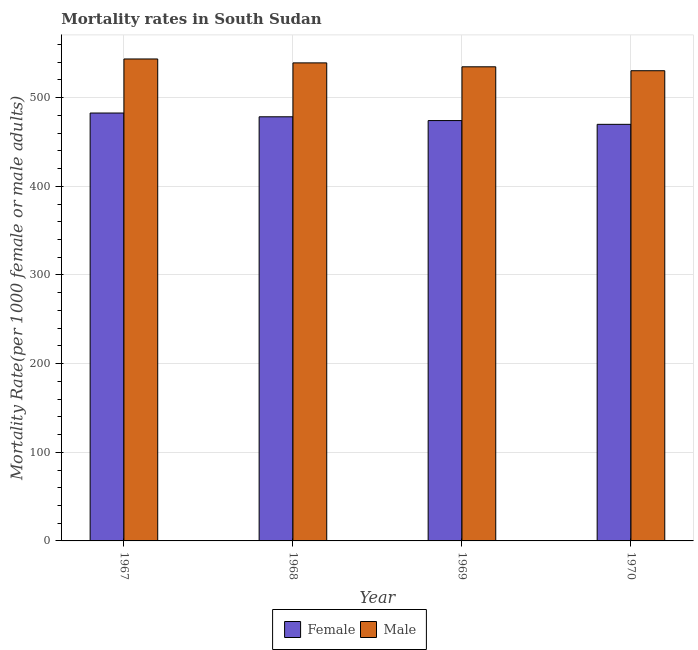How many different coloured bars are there?
Your answer should be compact. 2. Are the number of bars per tick equal to the number of legend labels?
Make the answer very short. Yes. Are the number of bars on each tick of the X-axis equal?
Provide a succinct answer. Yes. How many bars are there on the 4th tick from the left?
Your answer should be compact. 2. How many bars are there on the 3rd tick from the right?
Provide a succinct answer. 2. What is the label of the 1st group of bars from the left?
Ensure brevity in your answer.  1967. In how many cases, is the number of bars for a given year not equal to the number of legend labels?
Your answer should be compact. 0. What is the female mortality rate in 1969?
Make the answer very short. 474.2. Across all years, what is the maximum male mortality rate?
Make the answer very short. 543.68. Across all years, what is the minimum male mortality rate?
Your answer should be compact. 530.43. In which year was the female mortality rate maximum?
Your answer should be very brief. 1967. In which year was the male mortality rate minimum?
Offer a very short reply. 1970. What is the total female mortality rate in the graph?
Offer a terse response. 1905.31. What is the difference between the male mortality rate in 1967 and that in 1968?
Keep it short and to the point. 4.42. What is the difference between the female mortality rate in 1968 and the male mortality rate in 1967?
Your answer should be very brief. -4.25. What is the average female mortality rate per year?
Offer a very short reply. 476.33. In how many years, is the male mortality rate greater than 400?
Give a very brief answer. 4. What is the ratio of the male mortality rate in 1967 to that in 1969?
Offer a terse response. 1.02. Is the male mortality rate in 1967 less than that in 1970?
Your answer should be very brief. No. Is the difference between the male mortality rate in 1968 and 1969 greater than the difference between the female mortality rate in 1968 and 1969?
Keep it short and to the point. No. What is the difference between the highest and the second highest female mortality rate?
Keep it short and to the point. 4.25. What is the difference between the highest and the lowest male mortality rate?
Ensure brevity in your answer.  13.26. In how many years, is the female mortality rate greater than the average female mortality rate taken over all years?
Your answer should be very brief. 2. Is the sum of the male mortality rate in 1967 and 1968 greater than the maximum female mortality rate across all years?
Offer a terse response. Yes. What does the 2nd bar from the left in 1970 represents?
Your answer should be very brief. Male. How many bars are there?
Your answer should be very brief. 8. How many years are there in the graph?
Your response must be concise. 4. Where does the legend appear in the graph?
Give a very brief answer. Bottom center. How many legend labels are there?
Provide a succinct answer. 2. What is the title of the graph?
Make the answer very short. Mortality rates in South Sudan. Does "ODA received" appear as one of the legend labels in the graph?
Provide a short and direct response. No. What is the label or title of the X-axis?
Your answer should be compact. Year. What is the label or title of the Y-axis?
Ensure brevity in your answer.  Mortality Rate(per 1000 female or male adults). What is the Mortality Rate(per 1000 female or male adults) in Female in 1967?
Your answer should be compact. 482.71. What is the Mortality Rate(per 1000 female or male adults) in Male in 1967?
Ensure brevity in your answer.  543.68. What is the Mortality Rate(per 1000 female or male adults) in Female in 1968?
Offer a terse response. 478.45. What is the Mortality Rate(per 1000 female or male adults) in Male in 1968?
Your answer should be compact. 539.26. What is the Mortality Rate(per 1000 female or male adults) of Female in 1969?
Your answer should be very brief. 474.2. What is the Mortality Rate(per 1000 female or male adults) of Male in 1969?
Offer a terse response. 534.85. What is the Mortality Rate(per 1000 female or male adults) of Female in 1970?
Offer a terse response. 469.94. What is the Mortality Rate(per 1000 female or male adults) of Male in 1970?
Your answer should be very brief. 530.43. Across all years, what is the maximum Mortality Rate(per 1000 female or male adults) in Female?
Keep it short and to the point. 482.71. Across all years, what is the maximum Mortality Rate(per 1000 female or male adults) of Male?
Give a very brief answer. 543.68. Across all years, what is the minimum Mortality Rate(per 1000 female or male adults) in Female?
Your response must be concise. 469.94. Across all years, what is the minimum Mortality Rate(per 1000 female or male adults) of Male?
Your answer should be compact. 530.43. What is the total Mortality Rate(per 1000 female or male adults) of Female in the graph?
Offer a very short reply. 1905.31. What is the total Mortality Rate(per 1000 female or male adults) in Male in the graph?
Offer a very short reply. 2148.22. What is the difference between the Mortality Rate(per 1000 female or male adults) of Female in 1967 and that in 1968?
Your answer should be very brief. 4.25. What is the difference between the Mortality Rate(per 1000 female or male adults) in Male in 1967 and that in 1968?
Your answer should be compact. 4.42. What is the difference between the Mortality Rate(per 1000 female or male adults) of Female in 1967 and that in 1969?
Offer a very short reply. 8.51. What is the difference between the Mortality Rate(per 1000 female or male adults) of Male in 1967 and that in 1969?
Your answer should be compact. 8.84. What is the difference between the Mortality Rate(per 1000 female or male adults) of Female in 1967 and that in 1970?
Give a very brief answer. 12.76. What is the difference between the Mortality Rate(per 1000 female or male adults) in Male in 1967 and that in 1970?
Ensure brevity in your answer.  13.26. What is the difference between the Mortality Rate(per 1000 female or male adults) of Female in 1968 and that in 1969?
Provide a short and direct response. 4.25. What is the difference between the Mortality Rate(per 1000 female or male adults) of Male in 1968 and that in 1969?
Provide a succinct answer. 4.42. What is the difference between the Mortality Rate(per 1000 female or male adults) of Female in 1968 and that in 1970?
Your response must be concise. 8.51. What is the difference between the Mortality Rate(per 1000 female or male adults) of Male in 1968 and that in 1970?
Provide a short and direct response. 8.84. What is the difference between the Mortality Rate(per 1000 female or male adults) in Female in 1969 and that in 1970?
Your answer should be compact. 4.25. What is the difference between the Mortality Rate(per 1000 female or male adults) of Male in 1969 and that in 1970?
Keep it short and to the point. 4.42. What is the difference between the Mortality Rate(per 1000 female or male adults) of Female in 1967 and the Mortality Rate(per 1000 female or male adults) of Male in 1968?
Provide a succinct answer. -56.55. What is the difference between the Mortality Rate(per 1000 female or male adults) in Female in 1967 and the Mortality Rate(per 1000 female or male adults) in Male in 1969?
Give a very brief answer. -52.14. What is the difference between the Mortality Rate(per 1000 female or male adults) in Female in 1967 and the Mortality Rate(per 1000 female or male adults) in Male in 1970?
Keep it short and to the point. -47.72. What is the difference between the Mortality Rate(per 1000 female or male adults) in Female in 1968 and the Mortality Rate(per 1000 female or male adults) in Male in 1969?
Offer a terse response. -56.39. What is the difference between the Mortality Rate(per 1000 female or male adults) in Female in 1968 and the Mortality Rate(per 1000 female or male adults) in Male in 1970?
Offer a terse response. -51.97. What is the difference between the Mortality Rate(per 1000 female or male adults) in Female in 1969 and the Mortality Rate(per 1000 female or male adults) in Male in 1970?
Your answer should be very brief. -56.23. What is the average Mortality Rate(per 1000 female or male adults) in Female per year?
Give a very brief answer. 476.33. What is the average Mortality Rate(per 1000 female or male adults) in Male per year?
Your answer should be compact. 537.05. In the year 1967, what is the difference between the Mortality Rate(per 1000 female or male adults) in Female and Mortality Rate(per 1000 female or male adults) in Male?
Your answer should be very brief. -60.97. In the year 1968, what is the difference between the Mortality Rate(per 1000 female or male adults) in Female and Mortality Rate(per 1000 female or male adults) in Male?
Ensure brevity in your answer.  -60.81. In the year 1969, what is the difference between the Mortality Rate(per 1000 female or male adults) in Female and Mortality Rate(per 1000 female or male adults) in Male?
Give a very brief answer. -60.65. In the year 1970, what is the difference between the Mortality Rate(per 1000 female or male adults) of Female and Mortality Rate(per 1000 female or male adults) of Male?
Offer a terse response. -60.48. What is the ratio of the Mortality Rate(per 1000 female or male adults) of Female in 1967 to that in 1968?
Make the answer very short. 1.01. What is the ratio of the Mortality Rate(per 1000 female or male adults) in Male in 1967 to that in 1968?
Keep it short and to the point. 1.01. What is the ratio of the Mortality Rate(per 1000 female or male adults) of Female in 1967 to that in 1969?
Ensure brevity in your answer.  1.02. What is the ratio of the Mortality Rate(per 1000 female or male adults) in Male in 1967 to that in 1969?
Your answer should be very brief. 1.02. What is the ratio of the Mortality Rate(per 1000 female or male adults) of Female in 1967 to that in 1970?
Offer a terse response. 1.03. What is the ratio of the Mortality Rate(per 1000 female or male adults) in Male in 1967 to that in 1970?
Your response must be concise. 1.02. What is the ratio of the Mortality Rate(per 1000 female or male adults) in Female in 1968 to that in 1969?
Your answer should be compact. 1.01. What is the ratio of the Mortality Rate(per 1000 female or male adults) of Male in 1968 to that in 1969?
Provide a short and direct response. 1.01. What is the ratio of the Mortality Rate(per 1000 female or male adults) of Female in 1968 to that in 1970?
Your answer should be very brief. 1.02. What is the ratio of the Mortality Rate(per 1000 female or male adults) in Male in 1968 to that in 1970?
Give a very brief answer. 1.02. What is the ratio of the Mortality Rate(per 1000 female or male adults) of Female in 1969 to that in 1970?
Your answer should be compact. 1.01. What is the ratio of the Mortality Rate(per 1000 female or male adults) of Male in 1969 to that in 1970?
Your answer should be very brief. 1.01. What is the difference between the highest and the second highest Mortality Rate(per 1000 female or male adults) of Female?
Keep it short and to the point. 4.25. What is the difference between the highest and the second highest Mortality Rate(per 1000 female or male adults) of Male?
Your response must be concise. 4.42. What is the difference between the highest and the lowest Mortality Rate(per 1000 female or male adults) in Female?
Your answer should be compact. 12.76. What is the difference between the highest and the lowest Mortality Rate(per 1000 female or male adults) of Male?
Your answer should be compact. 13.26. 